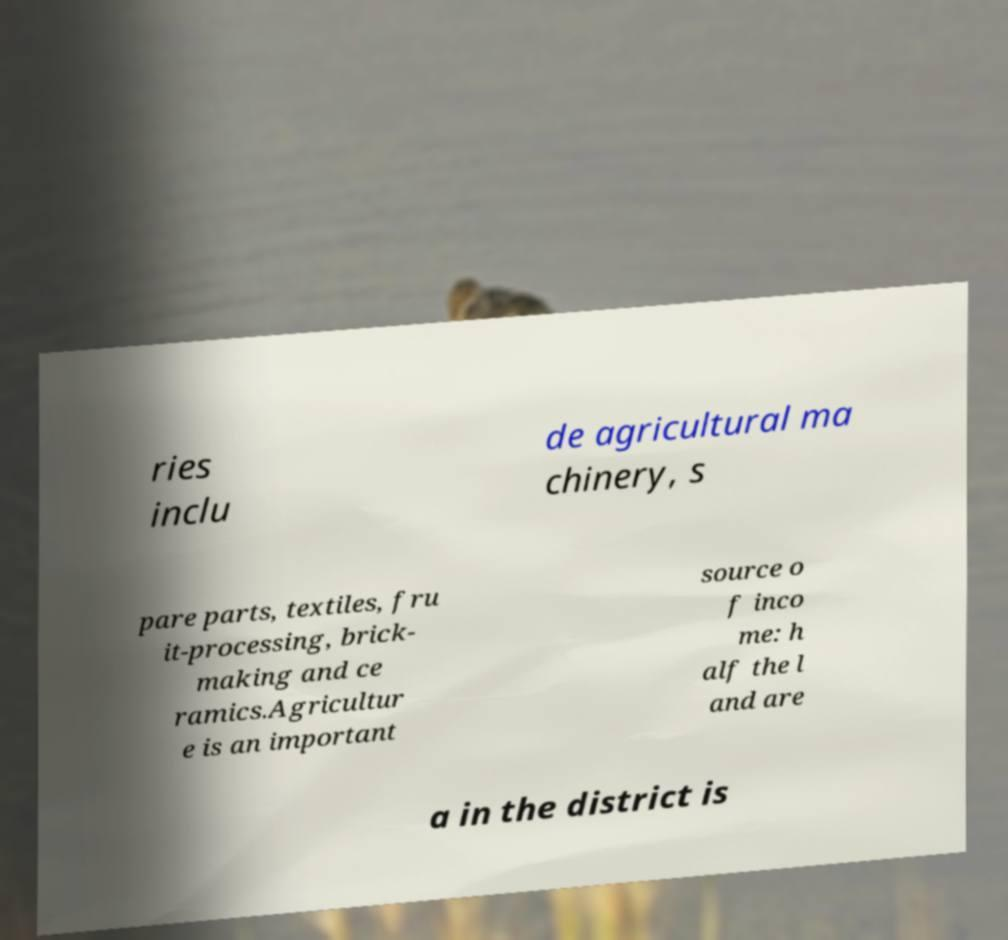Please identify and transcribe the text found in this image. ries inclu de agricultural ma chinery, s pare parts, textiles, fru it-processing, brick- making and ce ramics.Agricultur e is an important source o f inco me: h alf the l and are a in the district is 